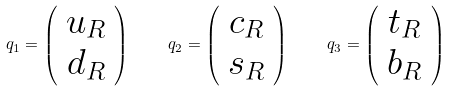<formula> <loc_0><loc_0><loc_500><loc_500>q _ { 1 } = \left ( \begin{array} { c } u _ { R } \\ d _ { R } \end{array} \right ) \quad q _ { 2 } = \left ( \begin{array} { c } c _ { R } \\ s _ { R } \end{array} \right ) \quad q _ { 3 } = \left ( \begin{array} { c } t _ { R } \\ b _ { R } \end{array} \right )</formula> 